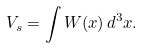<formula> <loc_0><loc_0><loc_500><loc_500>V _ { s } = \int W ( { x } ) \, d ^ { 3 } { x } .</formula> 